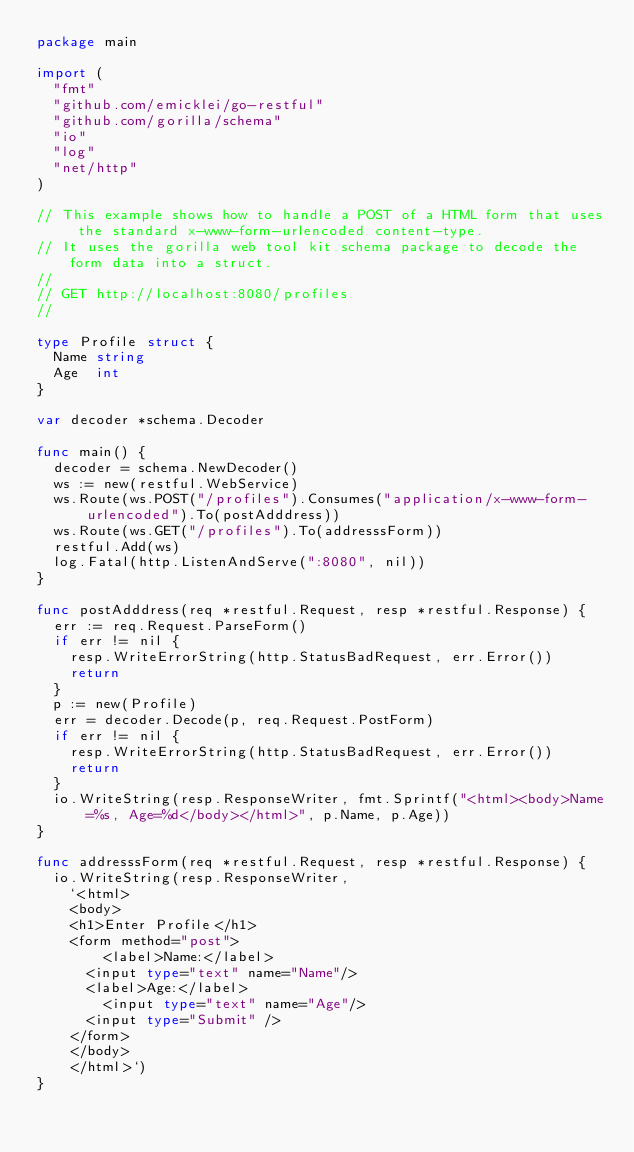Convert code to text. <code><loc_0><loc_0><loc_500><loc_500><_Go_>package main

import (
	"fmt"
	"github.com/emicklei/go-restful"
	"github.com/gorilla/schema"
	"io"
	"log"
	"net/http"
)

// This example shows how to handle a POST of a HTML form that uses the standard x-www-form-urlencoded content-type.
// It uses the gorilla web tool kit schema package to decode the form data into a struct.
//
// GET http://localhost:8080/profiles
//

type Profile struct {
	Name string
	Age  int
}

var decoder *schema.Decoder

func main() {
	decoder = schema.NewDecoder()
	ws := new(restful.WebService)
	ws.Route(ws.POST("/profiles").Consumes("application/x-www-form-urlencoded").To(postAdddress))
	ws.Route(ws.GET("/profiles").To(addresssForm))
	restful.Add(ws)
	log.Fatal(http.ListenAndServe(":8080", nil))
}

func postAdddress(req *restful.Request, resp *restful.Response) {
	err := req.Request.ParseForm()
	if err != nil {
		resp.WriteErrorString(http.StatusBadRequest, err.Error())
		return
	}
	p := new(Profile)
	err = decoder.Decode(p, req.Request.PostForm)
	if err != nil {
		resp.WriteErrorString(http.StatusBadRequest, err.Error())
		return
	}
	io.WriteString(resp.ResponseWriter, fmt.Sprintf("<html><body>Name=%s, Age=%d</body></html>", p.Name, p.Age))
}

func addresssForm(req *restful.Request, resp *restful.Response) {
	io.WriteString(resp.ResponseWriter,
		`<html>
		<body>
		<h1>Enter Profile</h1>
		<form method="post">
		    <label>Name:</label>
			<input type="text" name="Name"/>
			<label>Age:</label>
		    <input type="text" name="Age"/>
			<input type="Submit" />
		</form>
		</body>
		</html>`)
}
</code> 